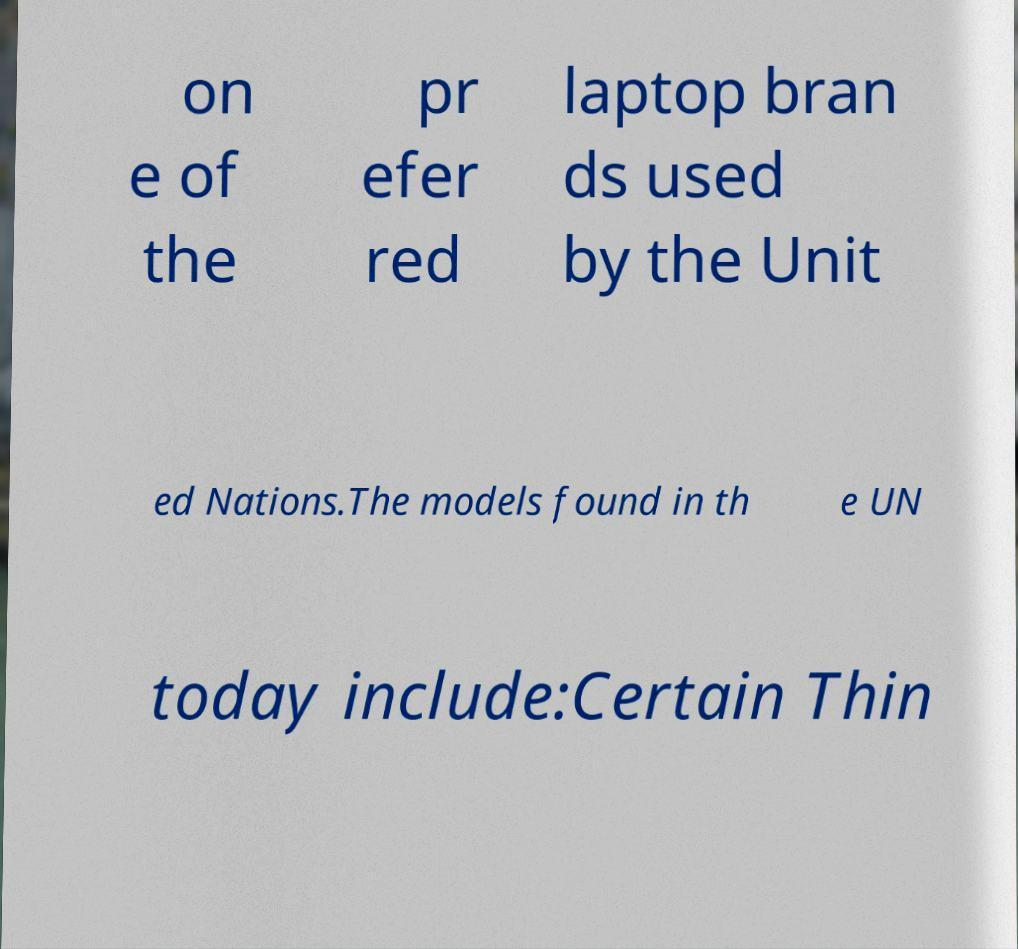Please read and relay the text visible in this image. What does it say? on e of the pr efer red laptop bran ds used by the Unit ed Nations.The models found in th e UN today include:Certain Thin 